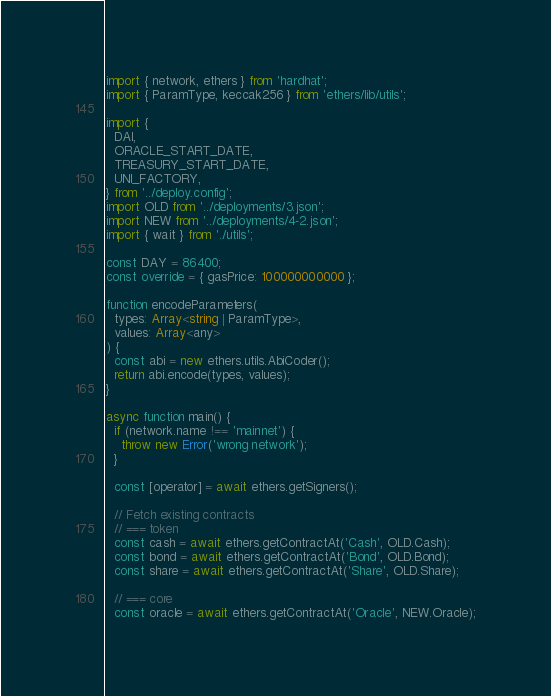Convert code to text. <code><loc_0><loc_0><loc_500><loc_500><_TypeScript_>import { network, ethers } from 'hardhat';
import { ParamType, keccak256 } from 'ethers/lib/utils';

import {
  DAI,
  ORACLE_START_DATE,
  TREASURY_START_DATE,
  UNI_FACTORY,
} from '../deploy.config';
import OLD from '../deployments/3.json';
import NEW from '../deployments/4-2.json';
import { wait } from './utils';

const DAY = 86400;
const override = { gasPrice: 100000000000 };

function encodeParameters(
  types: Array<string | ParamType>,
  values: Array<any>
) {
  const abi = new ethers.utils.AbiCoder();
  return abi.encode(types, values);
}

async function main() {
  if (network.name !== 'mainnet') {
    throw new Error('wrong network');
  }

  const [operator] = await ethers.getSigners();

  // Fetch existing contracts
  // === token
  const cash = await ethers.getContractAt('Cash', OLD.Cash);
  const bond = await ethers.getContractAt('Bond', OLD.Bond);
  const share = await ethers.getContractAt('Share', OLD.Share);

  // === core
  const oracle = await ethers.getContractAt('Oracle', NEW.Oracle);</code> 